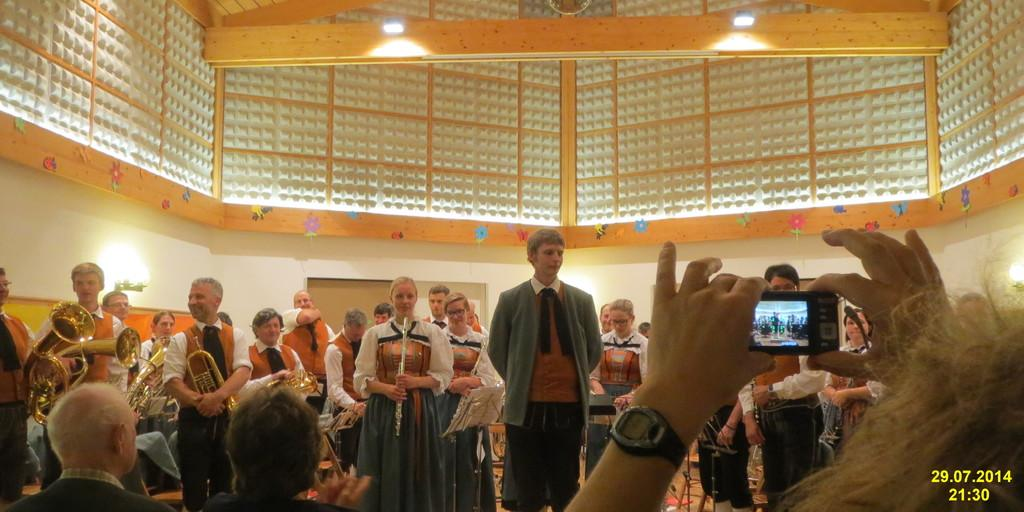<image>
Relay a brief, clear account of the picture shown. a building full of people with someone taking a picture and the date 29.07.2014 21:30 